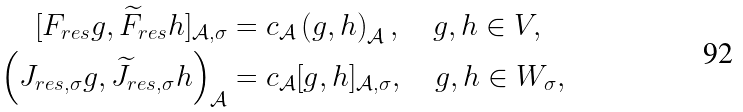<formula> <loc_0><loc_0><loc_500><loc_500>[ F _ { r e s } g , \widetilde { F } _ { r e s } h ] _ { \mathcal { A } , \sigma } & = c _ { \mathcal { A } } \left ( g , h \right ) _ { \mathcal { A } } , \quad g , h \in V , \\ \left ( J _ { r e s , \sigma } g , \widetilde { J } _ { r e s , \sigma } h \right ) _ { \mathcal { A } } & = c _ { \mathcal { A } } [ g , h ] _ { \mathcal { A } , \sigma } , \quad g , h \in W _ { \sigma } ,</formula> 